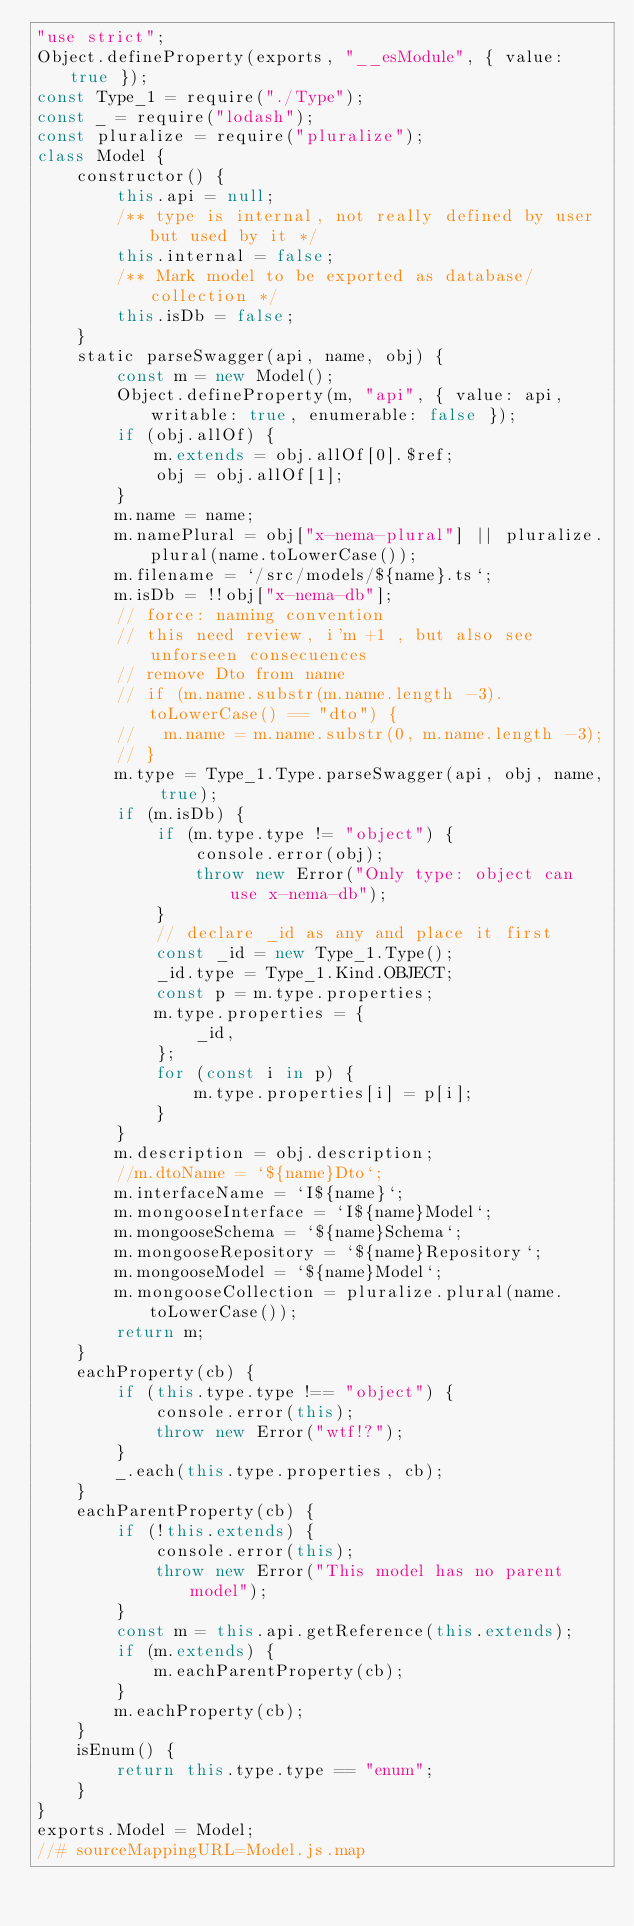Convert code to text. <code><loc_0><loc_0><loc_500><loc_500><_JavaScript_>"use strict";
Object.defineProperty(exports, "__esModule", { value: true });
const Type_1 = require("./Type");
const _ = require("lodash");
const pluralize = require("pluralize");
class Model {
    constructor() {
        this.api = null;
        /** type is internal, not really defined by user but used by it */
        this.internal = false;
        /** Mark model to be exported as database/collection */
        this.isDb = false;
    }
    static parseSwagger(api, name, obj) {
        const m = new Model();
        Object.defineProperty(m, "api", { value: api, writable: true, enumerable: false });
        if (obj.allOf) {
            m.extends = obj.allOf[0].$ref;
            obj = obj.allOf[1];
        }
        m.name = name;
        m.namePlural = obj["x-nema-plural"] || pluralize.plural(name.toLowerCase());
        m.filename = `/src/models/${name}.ts`;
        m.isDb = !!obj["x-nema-db"];
        // force: naming convention
        // this need review, i'm +1 , but also see unforseen consecuences
        // remove Dto from name
        // if (m.name.substr(m.name.length -3).toLowerCase() == "dto") {
        //   m.name = m.name.substr(0, m.name.length -3);
        // }
        m.type = Type_1.Type.parseSwagger(api, obj, name, true);
        if (m.isDb) {
            if (m.type.type != "object") {
                console.error(obj);
                throw new Error("Only type: object can use x-nema-db");
            }
            // declare _id as any and place it first
            const _id = new Type_1.Type();
            _id.type = Type_1.Kind.OBJECT;
            const p = m.type.properties;
            m.type.properties = {
                _id,
            };
            for (const i in p) {
                m.type.properties[i] = p[i];
            }
        }
        m.description = obj.description;
        //m.dtoName = `${name}Dto`;
        m.interfaceName = `I${name}`;
        m.mongooseInterface = `I${name}Model`;
        m.mongooseSchema = `${name}Schema`;
        m.mongooseRepository = `${name}Repository`;
        m.mongooseModel = `${name}Model`;
        m.mongooseCollection = pluralize.plural(name.toLowerCase());
        return m;
    }
    eachProperty(cb) {
        if (this.type.type !== "object") {
            console.error(this);
            throw new Error("wtf!?");
        }
        _.each(this.type.properties, cb);
    }
    eachParentProperty(cb) {
        if (!this.extends) {
            console.error(this);
            throw new Error("This model has no parent model");
        }
        const m = this.api.getReference(this.extends);
        if (m.extends) {
            m.eachParentProperty(cb);
        }
        m.eachProperty(cb);
    }
    isEnum() {
        return this.type.type == "enum";
    }
}
exports.Model = Model;
//# sourceMappingURL=Model.js.map</code> 